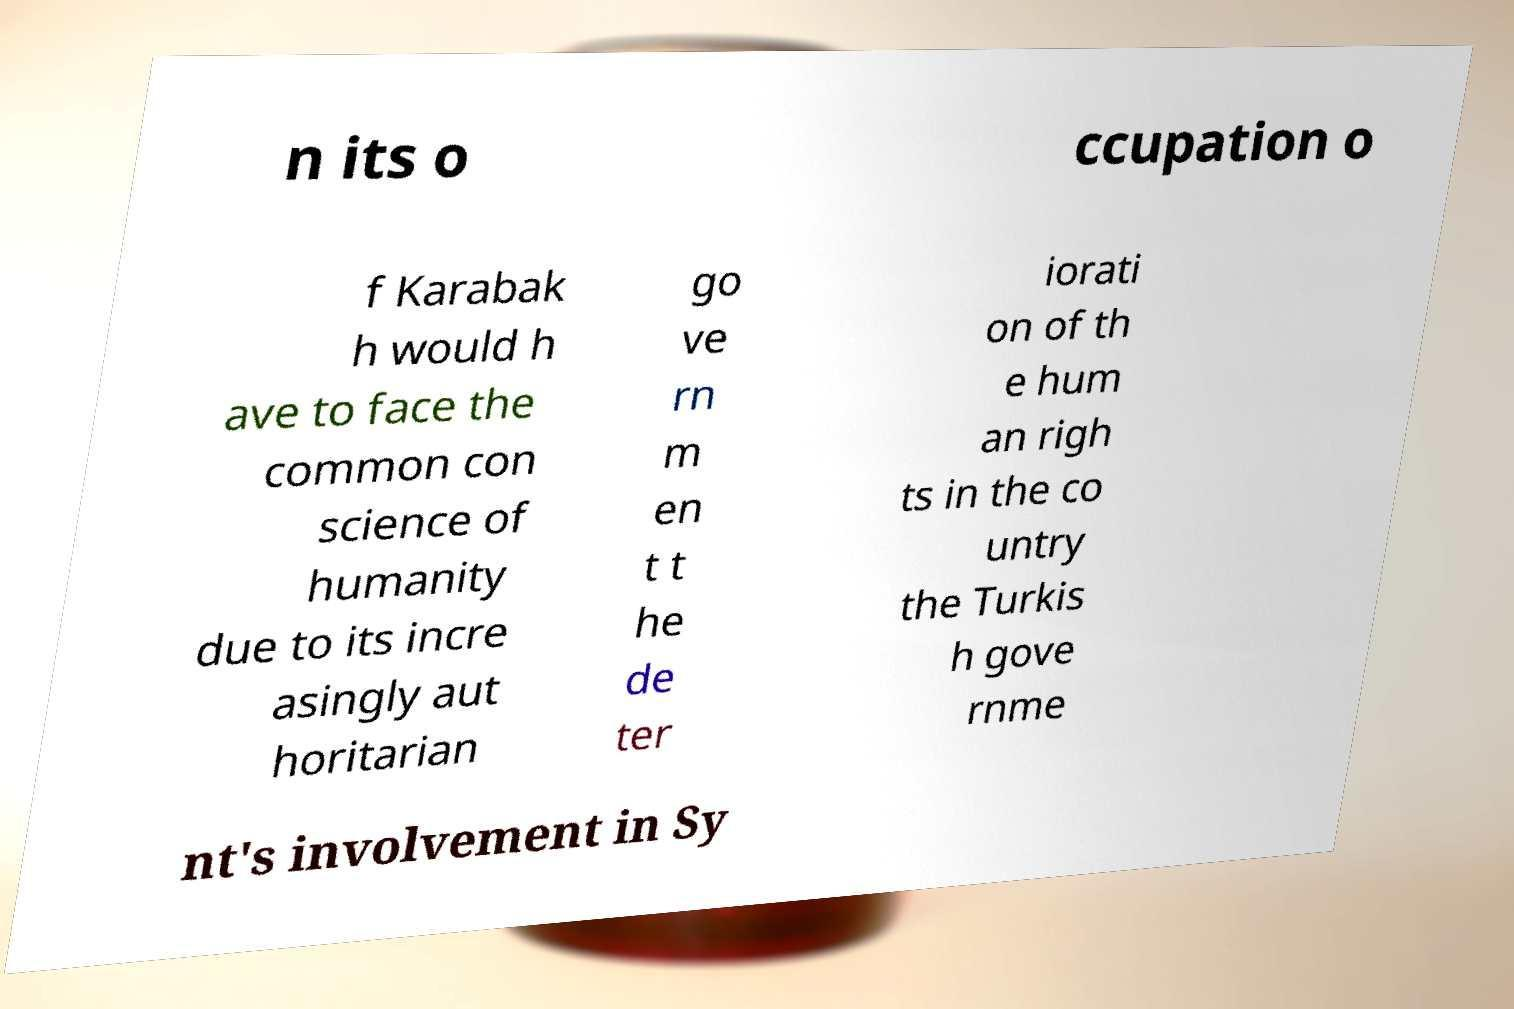There's text embedded in this image that I need extracted. Can you transcribe it verbatim? n its o ccupation o f Karabak h would h ave to face the common con science of humanity due to its incre asingly aut horitarian go ve rn m en t t he de ter iorati on of th e hum an righ ts in the co untry the Turkis h gove rnme nt's involvement in Sy 